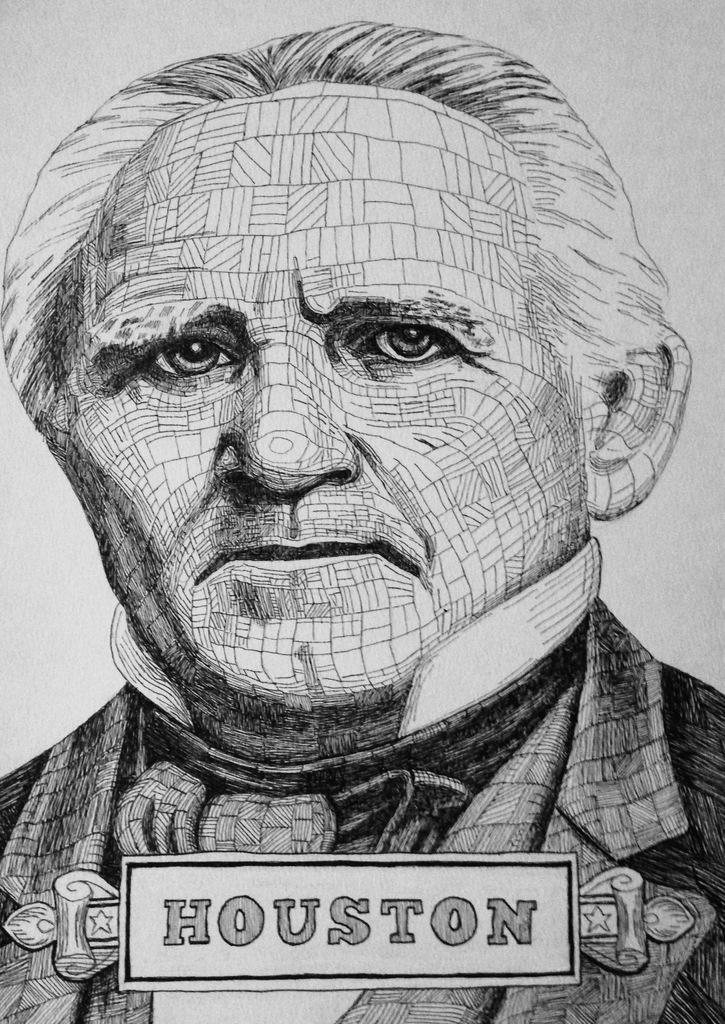What is the main subject of the image? The main subject of the image is a sketch of a man. What text is present at the bottom of the image? The word "HOUSTON" is written at the bottom of the image. What color is the background of the image? The background of the image is white in color. What type of zipper is visible on the man's clothing in the image? There is no zipper visible on the man's clothing in the image, as it is a sketch and not a photograph. 